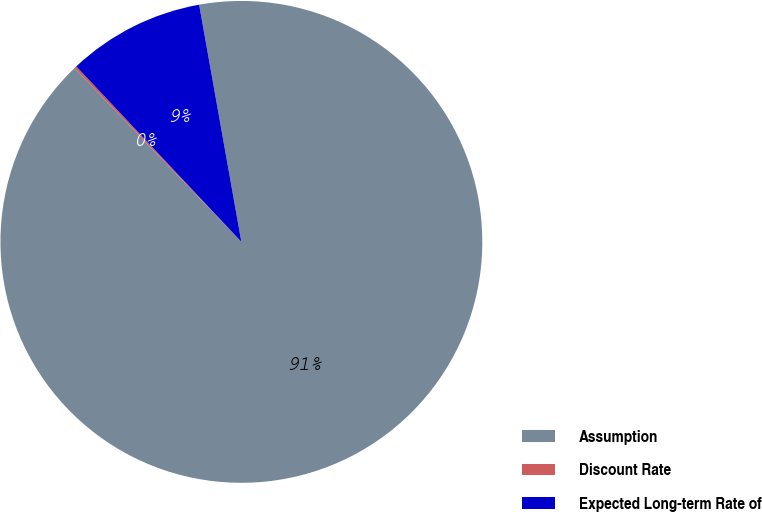<chart> <loc_0><loc_0><loc_500><loc_500><pie_chart><fcel>Assumption<fcel>Discount Rate<fcel>Expected Long-term Rate of<nl><fcel>90.63%<fcel>0.16%<fcel>9.21%<nl></chart> 